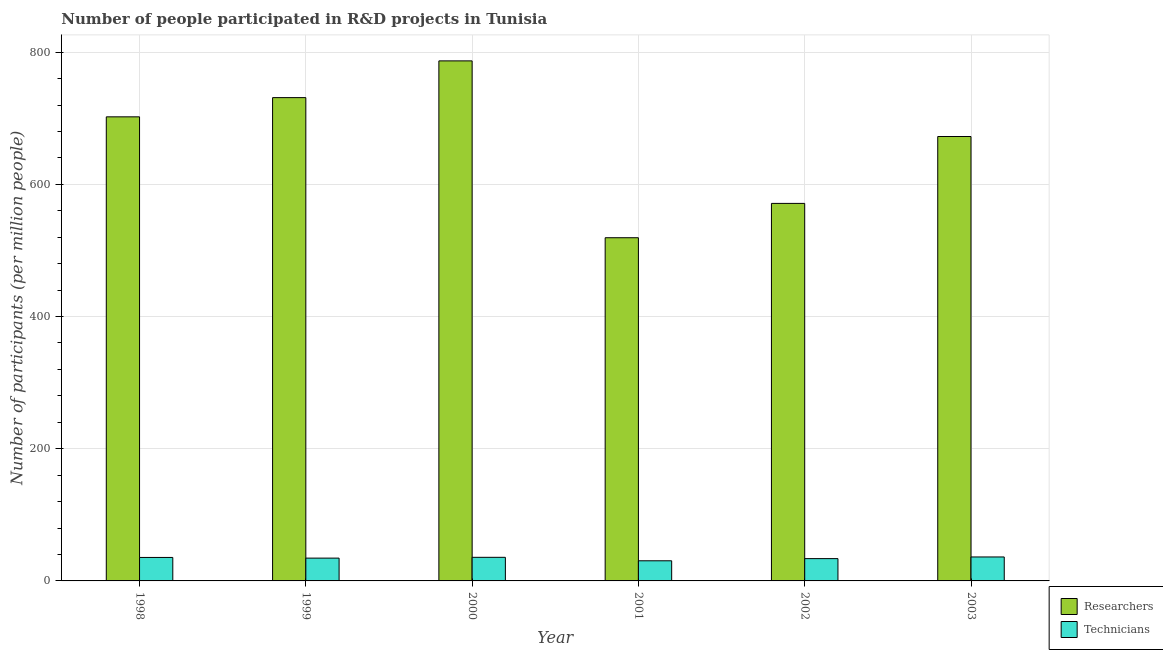How many different coloured bars are there?
Provide a short and direct response. 2. Are the number of bars on each tick of the X-axis equal?
Offer a terse response. Yes. What is the label of the 2nd group of bars from the left?
Provide a short and direct response. 1999. What is the number of technicians in 2002?
Your response must be concise. 33.74. Across all years, what is the maximum number of technicians?
Offer a terse response. 36.25. Across all years, what is the minimum number of technicians?
Make the answer very short. 30.46. What is the total number of researchers in the graph?
Offer a very short reply. 3982.87. What is the difference between the number of researchers in 2001 and that in 2003?
Give a very brief answer. -153.14. What is the difference between the number of researchers in 2000 and the number of technicians in 2003?
Your answer should be compact. 114.42. What is the average number of technicians per year?
Your answer should be compact. 34.36. In the year 2002, what is the difference between the number of researchers and number of technicians?
Your answer should be compact. 0. What is the ratio of the number of technicians in 1998 to that in 1999?
Provide a succinct answer. 1.03. Is the number of technicians in 1998 less than that in 1999?
Give a very brief answer. No. Is the difference between the number of researchers in 2000 and 2002 greater than the difference between the number of technicians in 2000 and 2002?
Your answer should be compact. No. What is the difference between the highest and the second highest number of technicians?
Your answer should be very brief. 0.56. What is the difference between the highest and the lowest number of researchers?
Offer a terse response. 267.56. What does the 2nd bar from the left in 1999 represents?
Offer a very short reply. Technicians. What does the 1st bar from the right in 2000 represents?
Offer a terse response. Technicians. Are the values on the major ticks of Y-axis written in scientific E-notation?
Give a very brief answer. No. Where does the legend appear in the graph?
Your response must be concise. Bottom right. What is the title of the graph?
Provide a succinct answer. Number of people participated in R&D projects in Tunisia. What is the label or title of the Y-axis?
Provide a succinct answer. Number of participants (per million people). What is the Number of participants (per million people) of Researchers in 1998?
Offer a very short reply. 702.12. What is the Number of participants (per million people) in Technicians in 1998?
Provide a short and direct response. 35.52. What is the Number of participants (per million people) in Researchers in 1999?
Your answer should be compact. 731.21. What is the Number of participants (per million people) of Technicians in 1999?
Your answer should be very brief. 34.49. What is the Number of participants (per million people) of Researchers in 2000?
Ensure brevity in your answer.  786.79. What is the Number of participants (per million people) of Technicians in 2000?
Provide a succinct answer. 35.7. What is the Number of participants (per million people) in Researchers in 2001?
Provide a succinct answer. 519.23. What is the Number of participants (per million people) in Technicians in 2001?
Keep it short and to the point. 30.46. What is the Number of participants (per million people) in Researchers in 2002?
Give a very brief answer. 571.16. What is the Number of participants (per million people) of Technicians in 2002?
Make the answer very short. 33.74. What is the Number of participants (per million people) in Researchers in 2003?
Keep it short and to the point. 672.37. What is the Number of participants (per million people) in Technicians in 2003?
Provide a succinct answer. 36.25. Across all years, what is the maximum Number of participants (per million people) in Researchers?
Your answer should be compact. 786.79. Across all years, what is the maximum Number of participants (per million people) in Technicians?
Provide a short and direct response. 36.25. Across all years, what is the minimum Number of participants (per million people) in Researchers?
Make the answer very short. 519.23. Across all years, what is the minimum Number of participants (per million people) of Technicians?
Offer a terse response. 30.46. What is the total Number of participants (per million people) of Researchers in the graph?
Your response must be concise. 3982.87. What is the total Number of participants (per million people) in Technicians in the graph?
Offer a very short reply. 206.16. What is the difference between the Number of participants (per million people) in Researchers in 1998 and that in 1999?
Provide a short and direct response. -29.09. What is the difference between the Number of participants (per million people) of Technicians in 1998 and that in 1999?
Keep it short and to the point. 1.03. What is the difference between the Number of participants (per million people) of Researchers in 1998 and that in 2000?
Keep it short and to the point. -84.67. What is the difference between the Number of participants (per million people) of Technicians in 1998 and that in 2000?
Give a very brief answer. -0.18. What is the difference between the Number of participants (per million people) of Researchers in 1998 and that in 2001?
Your response must be concise. 182.89. What is the difference between the Number of participants (per million people) in Technicians in 1998 and that in 2001?
Provide a short and direct response. 5.06. What is the difference between the Number of participants (per million people) in Researchers in 1998 and that in 2002?
Ensure brevity in your answer.  130.96. What is the difference between the Number of participants (per million people) of Technicians in 1998 and that in 2002?
Offer a terse response. 1.77. What is the difference between the Number of participants (per million people) in Researchers in 1998 and that in 2003?
Give a very brief answer. 29.75. What is the difference between the Number of participants (per million people) of Technicians in 1998 and that in 2003?
Offer a very short reply. -0.74. What is the difference between the Number of participants (per million people) in Researchers in 1999 and that in 2000?
Keep it short and to the point. -55.58. What is the difference between the Number of participants (per million people) in Technicians in 1999 and that in 2000?
Keep it short and to the point. -1.2. What is the difference between the Number of participants (per million people) of Researchers in 1999 and that in 2001?
Give a very brief answer. 211.98. What is the difference between the Number of participants (per million people) of Technicians in 1999 and that in 2001?
Make the answer very short. 4.03. What is the difference between the Number of participants (per million people) of Researchers in 1999 and that in 2002?
Your answer should be very brief. 160.05. What is the difference between the Number of participants (per million people) in Technicians in 1999 and that in 2002?
Your answer should be compact. 0.75. What is the difference between the Number of participants (per million people) of Researchers in 1999 and that in 2003?
Provide a short and direct response. 58.84. What is the difference between the Number of participants (per million people) in Technicians in 1999 and that in 2003?
Provide a succinct answer. -1.76. What is the difference between the Number of participants (per million people) of Researchers in 2000 and that in 2001?
Offer a very short reply. 267.56. What is the difference between the Number of participants (per million people) of Technicians in 2000 and that in 2001?
Offer a very short reply. 5.24. What is the difference between the Number of participants (per million people) in Researchers in 2000 and that in 2002?
Your answer should be compact. 215.63. What is the difference between the Number of participants (per million people) in Technicians in 2000 and that in 2002?
Ensure brevity in your answer.  1.95. What is the difference between the Number of participants (per million people) in Researchers in 2000 and that in 2003?
Offer a terse response. 114.42. What is the difference between the Number of participants (per million people) in Technicians in 2000 and that in 2003?
Offer a very short reply. -0.56. What is the difference between the Number of participants (per million people) of Researchers in 2001 and that in 2002?
Offer a very short reply. -51.93. What is the difference between the Number of participants (per million people) in Technicians in 2001 and that in 2002?
Your answer should be very brief. -3.29. What is the difference between the Number of participants (per million people) in Researchers in 2001 and that in 2003?
Give a very brief answer. -153.14. What is the difference between the Number of participants (per million people) in Technicians in 2001 and that in 2003?
Make the answer very short. -5.79. What is the difference between the Number of participants (per million people) of Researchers in 2002 and that in 2003?
Provide a short and direct response. -101.21. What is the difference between the Number of participants (per million people) in Technicians in 2002 and that in 2003?
Provide a succinct answer. -2.51. What is the difference between the Number of participants (per million people) in Researchers in 1998 and the Number of participants (per million people) in Technicians in 1999?
Your answer should be compact. 667.62. What is the difference between the Number of participants (per million people) of Researchers in 1998 and the Number of participants (per million people) of Technicians in 2000?
Your response must be concise. 666.42. What is the difference between the Number of participants (per million people) of Researchers in 1998 and the Number of participants (per million people) of Technicians in 2001?
Offer a terse response. 671.66. What is the difference between the Number of participants (per million people) of Researchers in 1998 and the Number of participants (per million people) of Technicians in 2002?
Make the answer very short. 668.37. What is the difference between the Number of participants (per million people) of Researchers in 1998 and the Number of participants (per million people) of Technicians in 2003?
Provide a short and direct response. 665.86. What is the difference between the Number of participants (per million people) in Researchers in 1999 and the Number of participants (per million people) in Technicians in 2000?
Offer a very short reply. 695.51. What is the difference between the Number of participants (per million people) in Researchers in 1999 and the Number of participants (per million people) in Technicians in 2001?
Your answer should be compact. 700.75. What is the difference between the Number of participants (per million people) in Researchers in 1999 and the Number of participants (per million people) in Technicians in 2002?
Make the answer very short. 697.46. What is the difference between the Number of participants (per million people) in Researchers in 1999 and the Number of participants (per million people) in Technicians in 2003?
Your response must be concise. 694.95. What is the difference between the Number of participants (per million people) of Researchers in 2000 and the Number of participants (per million people) of Technicians in 2001?
Your response must be concise. 756.33. What is the difference between the Number of participants (per million people) in Researchers in 2000 and the Number of participants (per million people) in Technicians in 2002?
Your answer should be very brief. 753.04. What is the difference between the Number of participants (per million people) of Researchers in 2000 and the Number of participants (per million people) of Technicians in 2003?
Ensure brevity in your answer.  750.53. What is the difference between the Number of participants (per million people) in Researchers in 2001 and the Number of participants (per million people) in Technicians in 2002?
Your answer should be compact. 485.48. What is the difference between the Number of participants (per million people) of Researchers in 2001 and the Number of participants (per million people) of Technicians in 2003?
Make the answer very short. 482.98. What is the difference between the Number of participants (per million people) in Researchers in 2002 and the Number of participants (per million people) in Technicians in 2003?
Provide a succinct answer. 534.9. What is the average Number of participants (per million people) of Researchers per year?
Make the answer very short. 663.81. What is the average Number of participants (per million people) of Technicians per year?
Offer a very short reply. 34.36. In the year 1998, what is the difference between the Number of participants (per million people) in Researchers and Number of participants (per million people) in Technicians?
Your answer should be compact. 666.6. In the year 1999, what is the difference between the Number of participants (per million people) in Researchers and Number of participants (per million people) in Technicians?
Give a very brief answer. 696.72. In the year 2000, what is the difference between the Number of participants (per million people) in Researchers and Number of participants (per million people) in Technicians?
Your answer should be compact. 751.09. In the year 2001, what is the difference between the Number of participants (per million people) of Researchers and Number of participants (per million people) of Technicians?
Provide a short and direct response. 488.77. In the year 2002, what is the difference between the Number of participants (per million people) of Researchers and Number of participants (per million people) of Technicians?
Provide a succinct answer. 537.41. In the year 2003, what is the difference between the Number of participants (per million people) in Researchers and Number of participants (per million people) in Technicians?
Your answer should be compact. 636.12. What is the ratio of the Number of participants (per million people) in Researchers in 1998 to that in 1999?
Provide a succinct answer. 0.96. What is the ratio of the Number of participants (per million people) of Technicians in 1998 to that in 1999?
Your response must be concise. 1.03. What is the ratio of the Number of participants (per million people) in Researchers in 1998 to that in 2000?
Offer a very short reply. 0.89. What is the ratio of the Number of participants (per million people) of Technicians in 1998 to that in 2000?
Provide a succinct answer. 0.99. What is the ratio of the Number of participants (per million people) of Researchers in 1998 to that in 2001?
Your answer should be compact. 1.35. What is the ratio of the Number of participants (per million people) in Technicians in 1998 to that in 2001?
Your answer should be compact. 1.17. What is the ratio of the Number of participants (per million people) in Researchers in 1998 to that in 2002?
Your answer should be very brief. 1.23. What is the ratio of the Number of participants (per million people) of Technicians in 1998 to that in 2002?
Keep it short and to the point. 1.05. What is the ratio of the Number of participants (per million people) of Researchers in 1998 to that in 2003?
Your answer should be very brief. 1.04. What is the ratio of the Number of participants (per million people) in Technicians in 1998 to that in 2003?
Provide a short and direct response. 0.98. What is the ratio of the Number of participants (per million people) of Researchers in 1999 to that in 2000?
Provide a succinct answer. 0.93. What is the ratio of the Number of participants (per million people) of Technicians in 1999 to that in 2000?
Offer a very short reply. 0.97. What is the ratio of the Number of participants (per million people) in Researchers in 1999 to that in 2001?
Give a very brief answer. 1.41. What is the ratio of the Number of participants (per million people) of Technicians in 1999 to that in 2001?
Your response must be concise. 1.13. What is the ratio of the Number of participants (per million people) of Researchers in 1999 to that in 2002?
Ensure brevity in your answer.  1.28. What is the ratio of the Number of participants (per million people) in Technicians in 1999 to that in 2002?
Provide a short and direct response. 1.02. What is the ratio of the Number of participants (per million people) of Researchers in 1999 to that in 2003?
Keep it short and to the point. 1.09. What is the ratio of the Number of participants (per million people) in Technicians in 1999 to that in 2003?
Ensure brevity in your answer.  0.95. What is the ratio of the Number of participants (per million people) in Researchers in 2000 to that in 2001?
Give a very brief answer. 1.52. What is the ratio of the Number of participants (per million people) in Technicians in 2000 to that in 2001?
Offer a very short reply. 1.17. What is the ratio of the Number of participants (per million people) in Researchers in 2000 to that in 2002?
Give a very brief answer. 1.38. What is the ratio of the Number of participants (per million people) of Technicians in 2000 to that in 2002?
Offer a terse response. 1.06. What is the ratio of the Number of participants (per million people) of Researchers in 2000 to that in 2003?
Provide a succinct answer. 1.17. What is the ratio of the Number of participants (per million people) of Technicians in 2000 to that in 2003?
Offer a very short reply. 0.98. What is the ratio of the Number of participants (per million people) of Researchers in 2001 to that in 2002?
Provide a short and direct response. 0.91. What is the ratio of the Number of participants (per million people) of Technicians in 2001 to that in 2002?
Keep it short and to the point. 0.9. What is the ratio of the Number of participants (per million people) in Researchers in 2001 to that in 2003?
Ensure brevity in your answer.  0.77. What is the ratio of the Number of participants (per million people) of Technicians in 2001 to that in 2003?
Ensure brevity in your answer.  0.84. What is the ratio of the Number of participants (per million people) of Researchers in 2002 to that in 2003?
Keep it short and to the point. 0.85. What is the ratio of the Number of participants (per million people) of Technicians in 2002 to that in 2003?
Your response must be concise. 0.93. What is the difference between the highest and the second highest Number of participants (per million people) of Researchers?
Make the answer very short. 55.58. What is the difference between the highest and the second highest Number of participants (per million people) of Technicians?
Provide a succinct answer. 0.56. What is the difference between the highest and the lowest Number of participants (per million people) in Researchers?
Your response must be concise. 267.56. What is the difference between the highest and the lowest Number of participants (per million people) in Technicians?
Give a very brief answer. 5.79. 